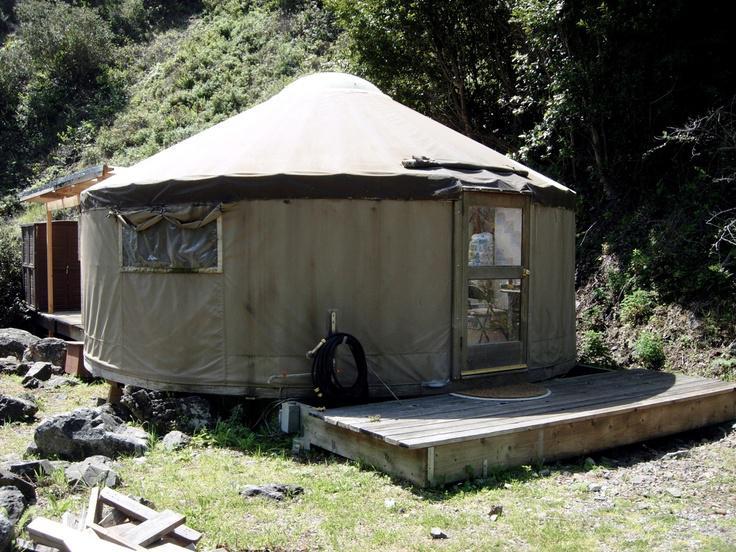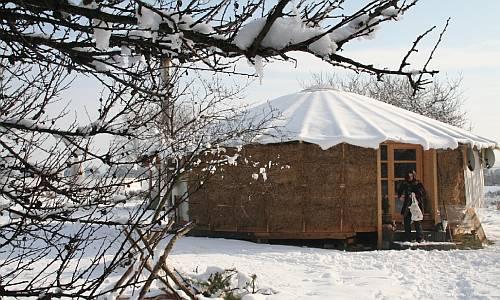The first image is the image on the left, the second image is the image on the right. Assess this claim about the two images: "A stovepipe extends upward from the roof of the yurt in the image on the left.". Correct or not? Answer yes or no. No. 